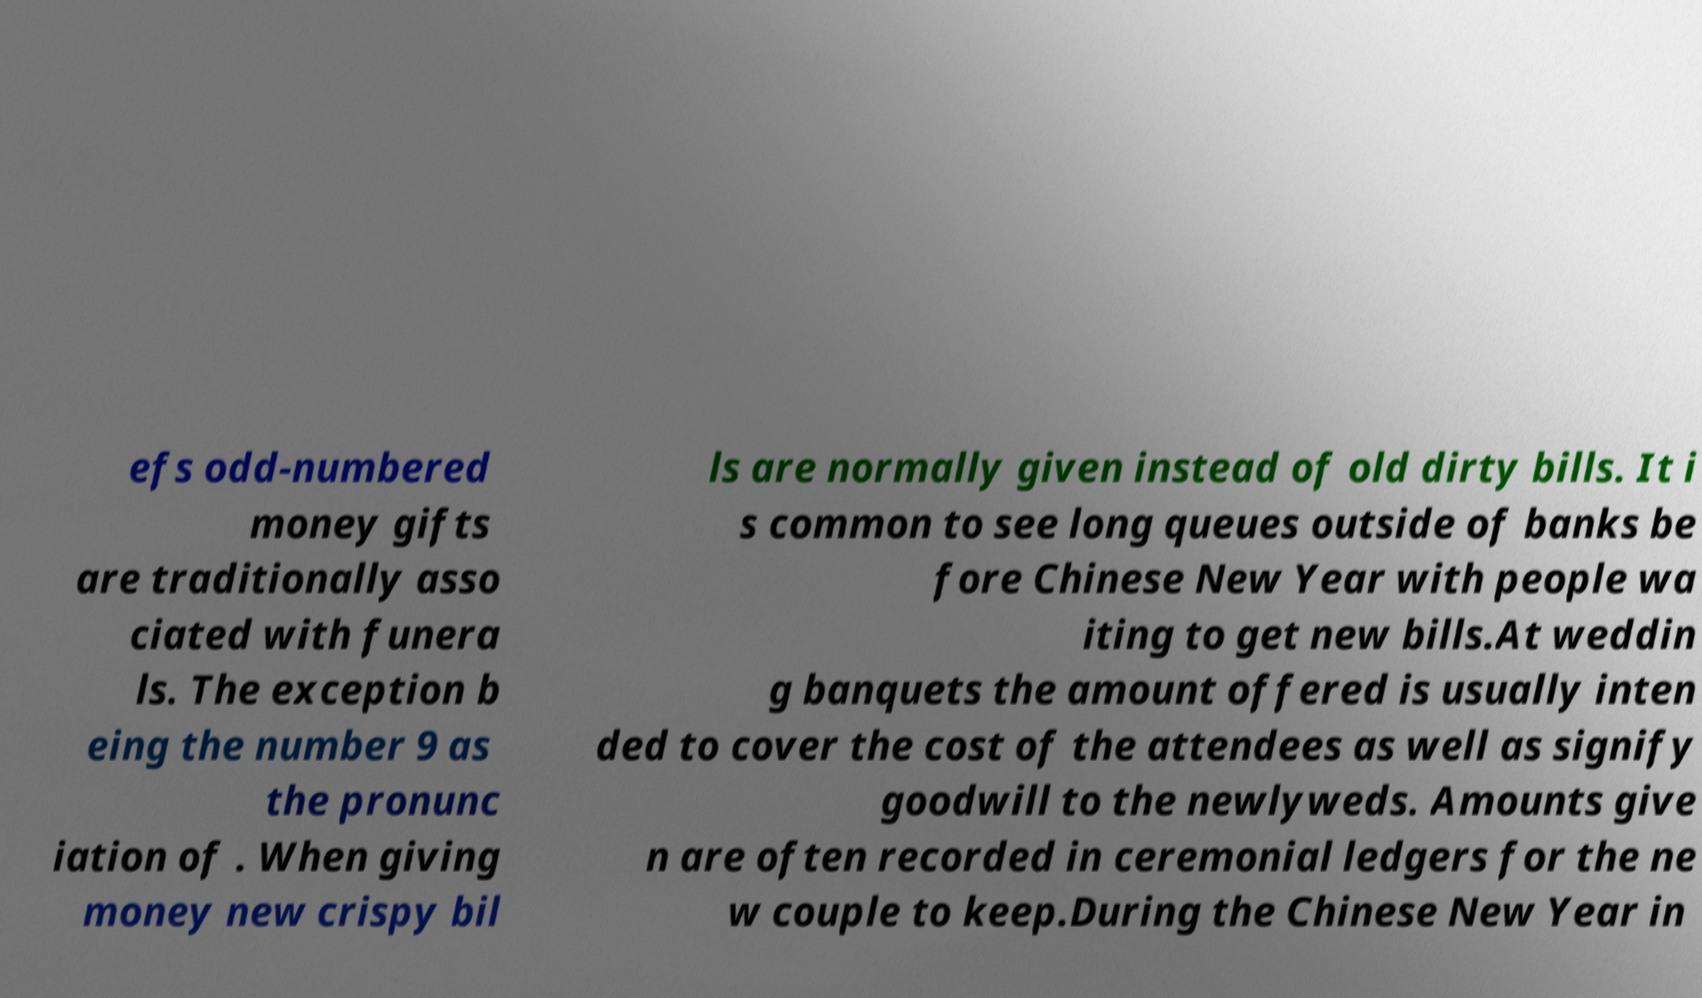Could you assist in decoding the text presented in this image and type it out clearly? efs odd-numbered money gifts are traditionally asso ciated with funera ls. The exception b eing the number 9 as the pronunc iation of . When giving money new crispy bil ls are normally given instead of old dirty bills. It i s common to see long queues outside of banks be fore Chinese New Year with people wa iting to get new bills.At weddin g banquets the amount offered is usually inten ded to cover the cost of the attendees as well as signify goodwill to the newlyweds. Amounts give n are often recorded in ceremonial ledgers for the ne w couple to keep.During the Chinese New Year in 